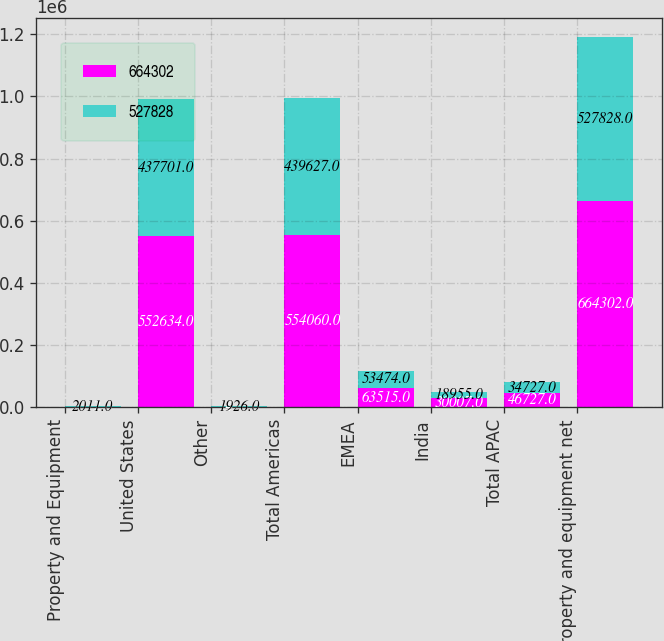Convert chart. <chart><loc_0><loc_0><loc_500><loc_500><stacked_bar_chart><ecel><fcel>Property and Equipment<fcel>United States<fcel>Other<fcel>Total Americas<fcel>EMEA<fcel>India<fcel>Total APAC<fcel>Property and equipment net<nl><fcel>664302<fcel>2012<fcel>552634<fcel>1426<fcel>554060<fcel>63515<fcel>30007<fcel>46727<fcel>664302<nl><fcel>527828<fcel>2011<fcel>437701<fcel>1926<fcel>439627<fcel>53474<fcel>18955<fcel>34727<fcel>527828<nl></chart> 